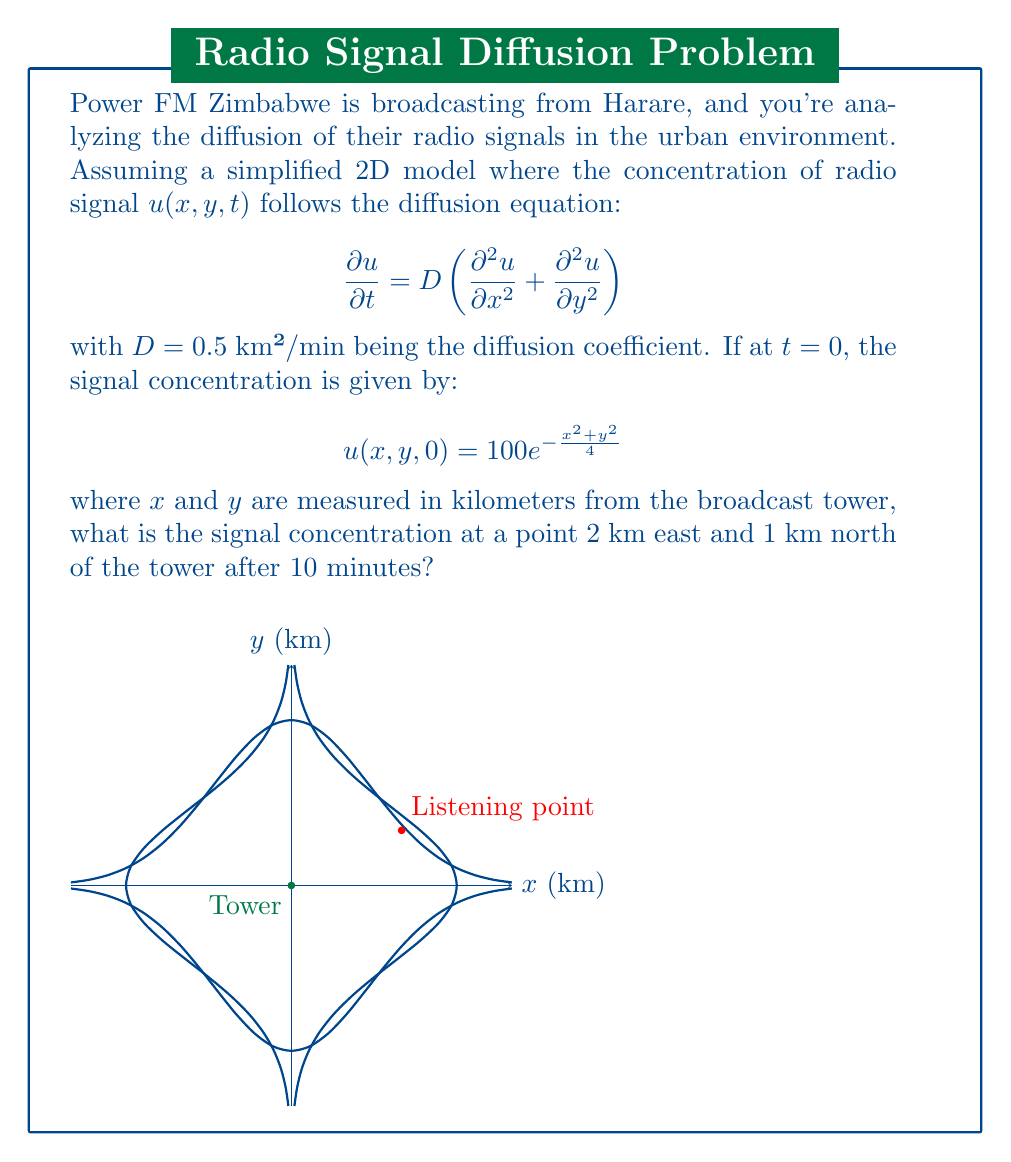Help me with this question. To solve this problem, we need to use the solution to the 2D diffusion equation with an initial Gaussian distribution. The general solution is:

$$u(x,y,t) = \frac{100}{1+Dt}\exp\left(-\frac{x^2+y^2}{4(1+Dt)}\right)$$

Let's follow these steps:

1) We're given $D = 0.5$ km²/min and $t = 10$ min.

2) The point of interest is at $(x,y) = (2,1)$ km.

3) Let's substitute these values into the solution:

   $$u(2,1,10) = \frac{100}{1+0.5(10)}\exp\left(-\frac{2^2+1^2}{4(1+0.5(10))}\right)$$

4) Simplify the denominator in the fraction:
   $$u(2,1,10) = \frac{100}{6}\exp\left(-\frac{5}{4(6)}\right)$$

5) Simplify inside the exponential:
   $$u(2,1,10) = \frac{100}{6}\exp\left(-\frac{5}{24}\right)$$

6) Calculate:
   $$u(2,1,10) \approx 16.67 \cdot 0.8111 \approx 13.52$$

Therefore, the signal concentration at the given point after 10 minutes is approximately 13.52 units.
Answer: $13.52$ units 